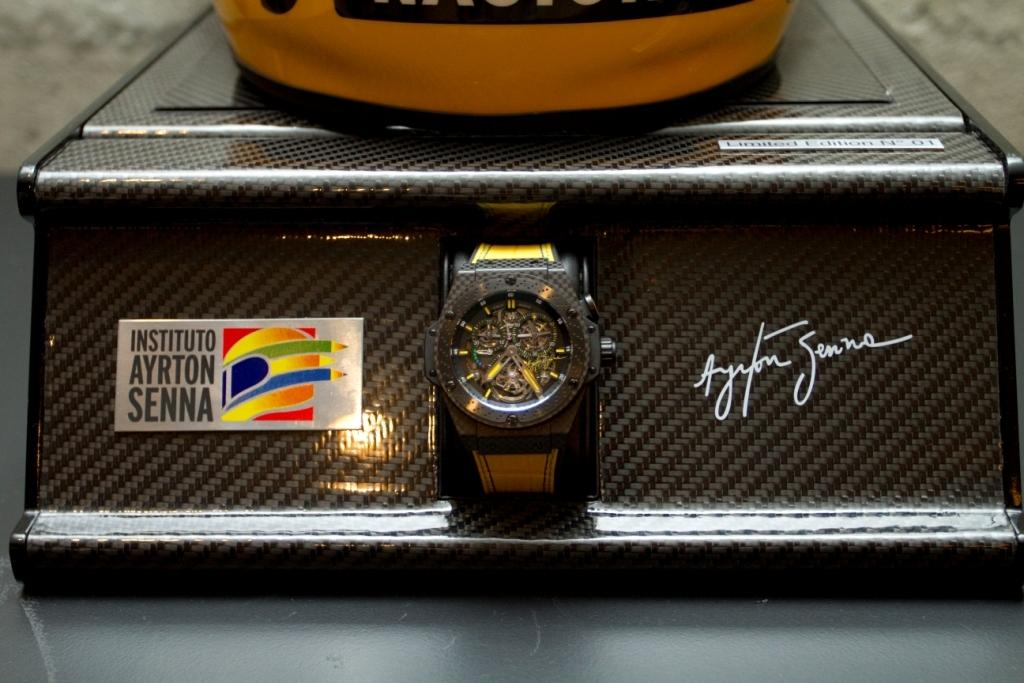<image>
Relay a brief, clear account of the picture shown. Instituto Ayrton Senna watch on display that is the color brown. 